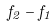<formula> <loc_0><loc_0><loc_500><loc_500>f _ { 2 } - f _ { 1 }</formula> 